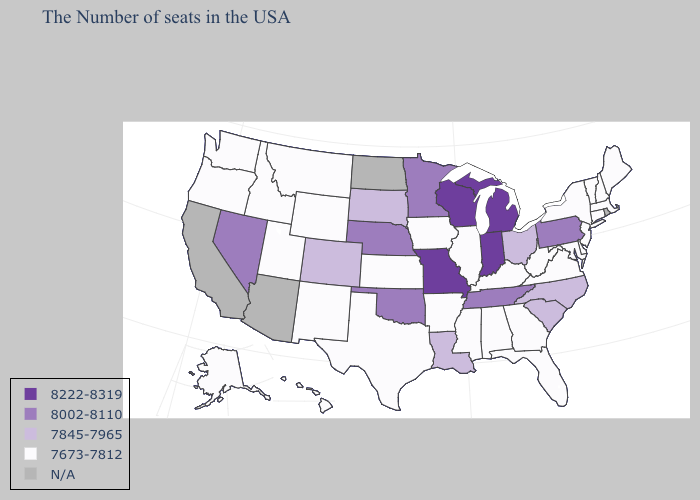What is the highest value in the USA?
Short answer required. 8222-8319. Among the states that border Nevada , which have the lowest value?
Quick response, please. Utah, Idaho, Oregon. Name the states that have a value in the range 8222-8319?
Answer briefly. Michigan, Indiana, Wisconsin, Missouri. What is the highest value in the South ?
Concise answer only. 8002-8110. Name the states that have a value in the range 7673-7812?
Short answer required. Maine, Massachusetts, New Hampshire, Vermont, Connecticut, New York, New Jersey, Delaware, Maryland, Virginia, West Virginia, Florida, Georgia, Kentucky, Alabama, Illinois, Mississippi, Arkansas, Iowa, Kansas, Texas, Wyoming, New Mexico, Utah, Montana, Idaho, Washington, Oregon, Alaska, Hawaii. What is the lowest value in states that border Arkansas?
Keep it brief. 7673-7812. Name the states that have a value in the range 7673-7812?
Short answer required. Maine, Massachusetts, New Hampshire, Vermont, Connecticut, New York, New Jersey, Delaware, Maryland, Virginia, West Virginia, Florida, Georgia, Kentucky, Alabama, Illinois, Mississippi, Arkansas, Iowa, Kansas, Texas, Wyoming, New Mexico, Utah, Montana, Idaho, Washington, Oregon, Alaska, Hawaii. Name the states that have a value in the range 8222-8319?
Be succinct. Michigan, Indiana, Wisconsin, Missouri. What is the lowest value in the Northeast?
Concise answer only. 7673-7812. What is the highest value in the USA?
Write a very short answer. 8222-8319. What is the value of Utah?
Write a very short answer. 7673-7812. What is the value of Connecticut?
Be succinct. 7673-7812. Which states have the highest value in the USA?
Short answer required. Michigan, Indiana, Wisconsin, Missouri. What is the lowest value in states that border Connecticut?
Give a very brief answer. 7673-7812. Does the map have missing data?
Quick response, please. Yes. 